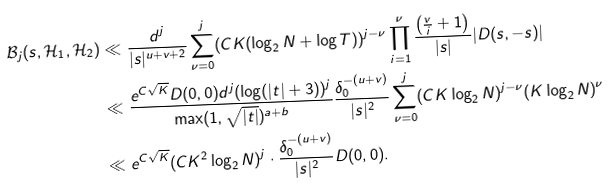Convert formula to latex. <formula><loc_0><loc_0><loc_500><loc_500>\mathcal { B } _ { j } ( s , \mathcal { H } _ { 1 } , \mathcal { H } _ { 2 } ) & \ll \frac { d ^ { j } } { | s | ^ { u + v + 2 } } \sum ^ { j } _ { \nu = 0 } ( C K ( \log _ { 2 } N + \log T ) ) ^ { j - \nu } \prod ^ { \nu } _ { i = 1 } \frac { \left ( \frac { v } { i } + 1 \right ) } { | s | } | D ( s , - s ) | \\ & \ll \frac { e ^ { C \sqrt { K } } D ( 0 , 0 ) d ^ { j } ( \log ( | t | + 3 ) ) ^ { j } } { \max ( 1 , \sqrt { | t | } ) ^ { a + b } } \frac { \delta ^ { - ( u + v ) } _ { 0 } } { | s | ^ { 2 } } \sum ^ { j } _ { \nu = 0 } ( C K \log _ { 2 } N ) ^ { j - \nu } ( K \log _ { 2 } N ) ^ { \nu } \\ & \ll e ^ { C \sqrt { K } } ( C K ^ { 2 } \log _ { 2 } N ) ^ { j } \cdot \frac { \delta ^ { - ( u + v ) } _ { 0 } } { | s | ^ { 2 } } D ( 0 , 0 ) .</formula> 